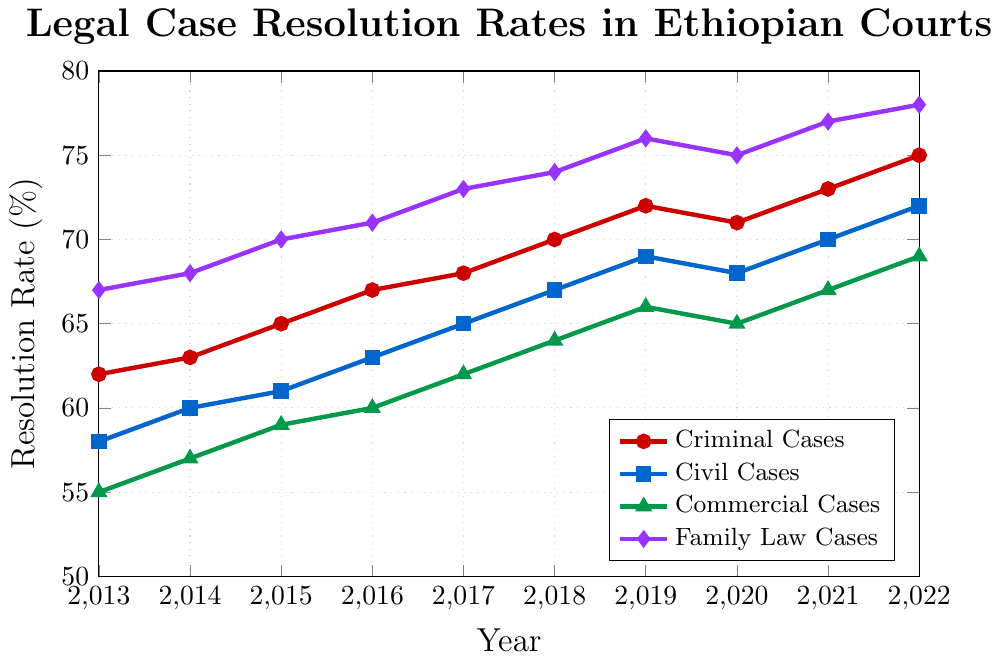What year did criminal cases have the lowest resolution rate? Examine the line representing criminal cases, find the year aligned with the lowest value. In this case, the value is 62 in the year 2013.
Answer: 2013 Compare the resolution rate of civil cases in 2015 and 2017. Which year had a higher rate? Look at the line representing civil cases. For 2015, the rate is 61, and for 2017, the rate is 65. Since 65 is greater than 61, 2017 had a higher rate.
Answer: 2017 What is the average resolution rate for family law cases from 2013 to 2015? Sum the rates for family law cases from 2013 to 2015: 67 + 68 + 70 = 205. Divide by the number of years (3): 205/3 = 68.33
Answer: 68.33 By how many percentage points did the resolution rate of commercial cases increase from 2013 to 2022? Subtract the 2013 value (55) for commercial cases from the 2022 value (69): 69 - 55 = 14
Answer: 14 Which case type had the most significant increase in resolution rate from 2019 to 2020? Compare the increases for each case type from 2019 to 2020: Criminal (72 to 71), Civil (69 to 68), Commercial (66 to 65), Family (76 to 75). Each case type except Criminal decreased by 1. Criminal increased the most by 1.
Answer: Criminal Cases Which case type had consistently higher resolution rates from 2013 to 2022? Look at the trend lines. The family law cases line is consistently at a higher position compared to other lines throughout the years 2013 to 2022.
Answer: Family Law Cases What is the total resolution rate for all types of cases in 2020? Sum the rates of all case types for 2020: 71 (criminal) + 68 (civil) + 65 (commercial) + 75 (family) = 279
Answer: 279 In which year did civil cases first reach a resolution rate of 70%? Follow the line for civil cases and find the year when the rate first hits or exceeds 70. That occurs in 2021.
Answer: 2021 